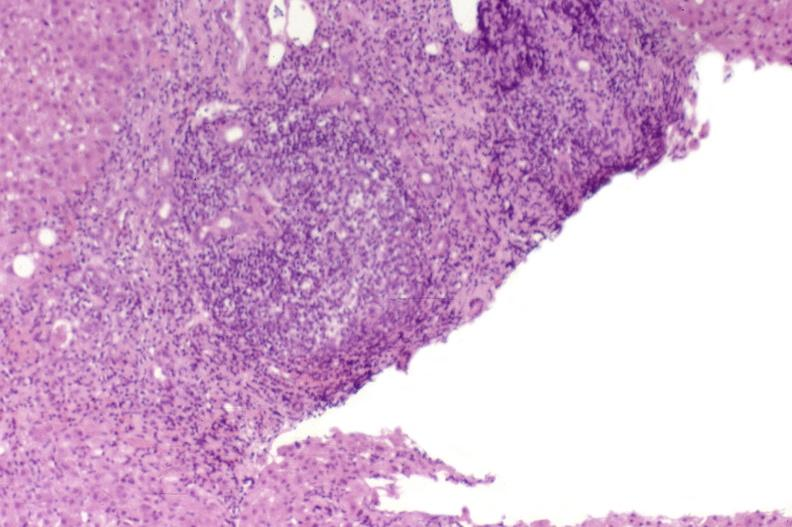s liver present?
Answer the question using a single word or phrase. Yes 